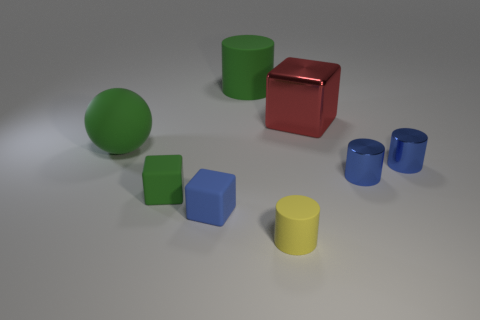There is a big green object on the right side of the large rubber ball; is there a cube that is to the left of it? Yes, there is indeed a cube to the left of the large green sphere. It's a smaller blue cube situated in close proximity to the green object, adding a nice contrast of both shape and color in the scene. 